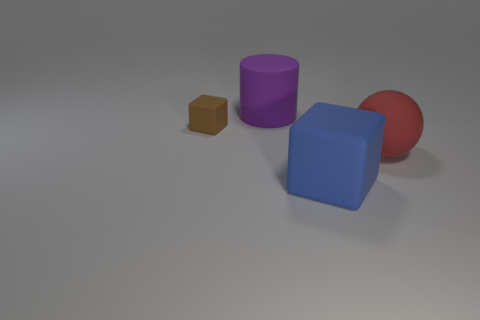Add 2 small brown cubes. How many objects exist? 6 Subtract all purple cylinders. How many gray blocks are left? 0 Subtract all large purple things. Subtract all big spheres. How many objects are left? 2 Add 2 large spheres. How many large spheres are left? 3 Add 4 tiny red rubber blocks. How many tiny red rubber blocks exist? 4 Subtract all brown cubes. How many cubes are left? 1 Subtract 0 cyan spheres. How many objects are left? 4 Subtract all cylinders. How many objects are left? 3 Subtract 1 blocks. How many blocks are left? 1 Subtract all blue cubes. Subtract all gray cylinders. How many cubes are left? 1 